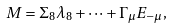Convert formula to latex. <formula><loc_0><loc_0><loc_500><loc_500>M = \Sigma _ { 8 } \lambda _ { 8 } + \dots + \Gamma _ { \mu } E _ { - \mu } ,</formula> 